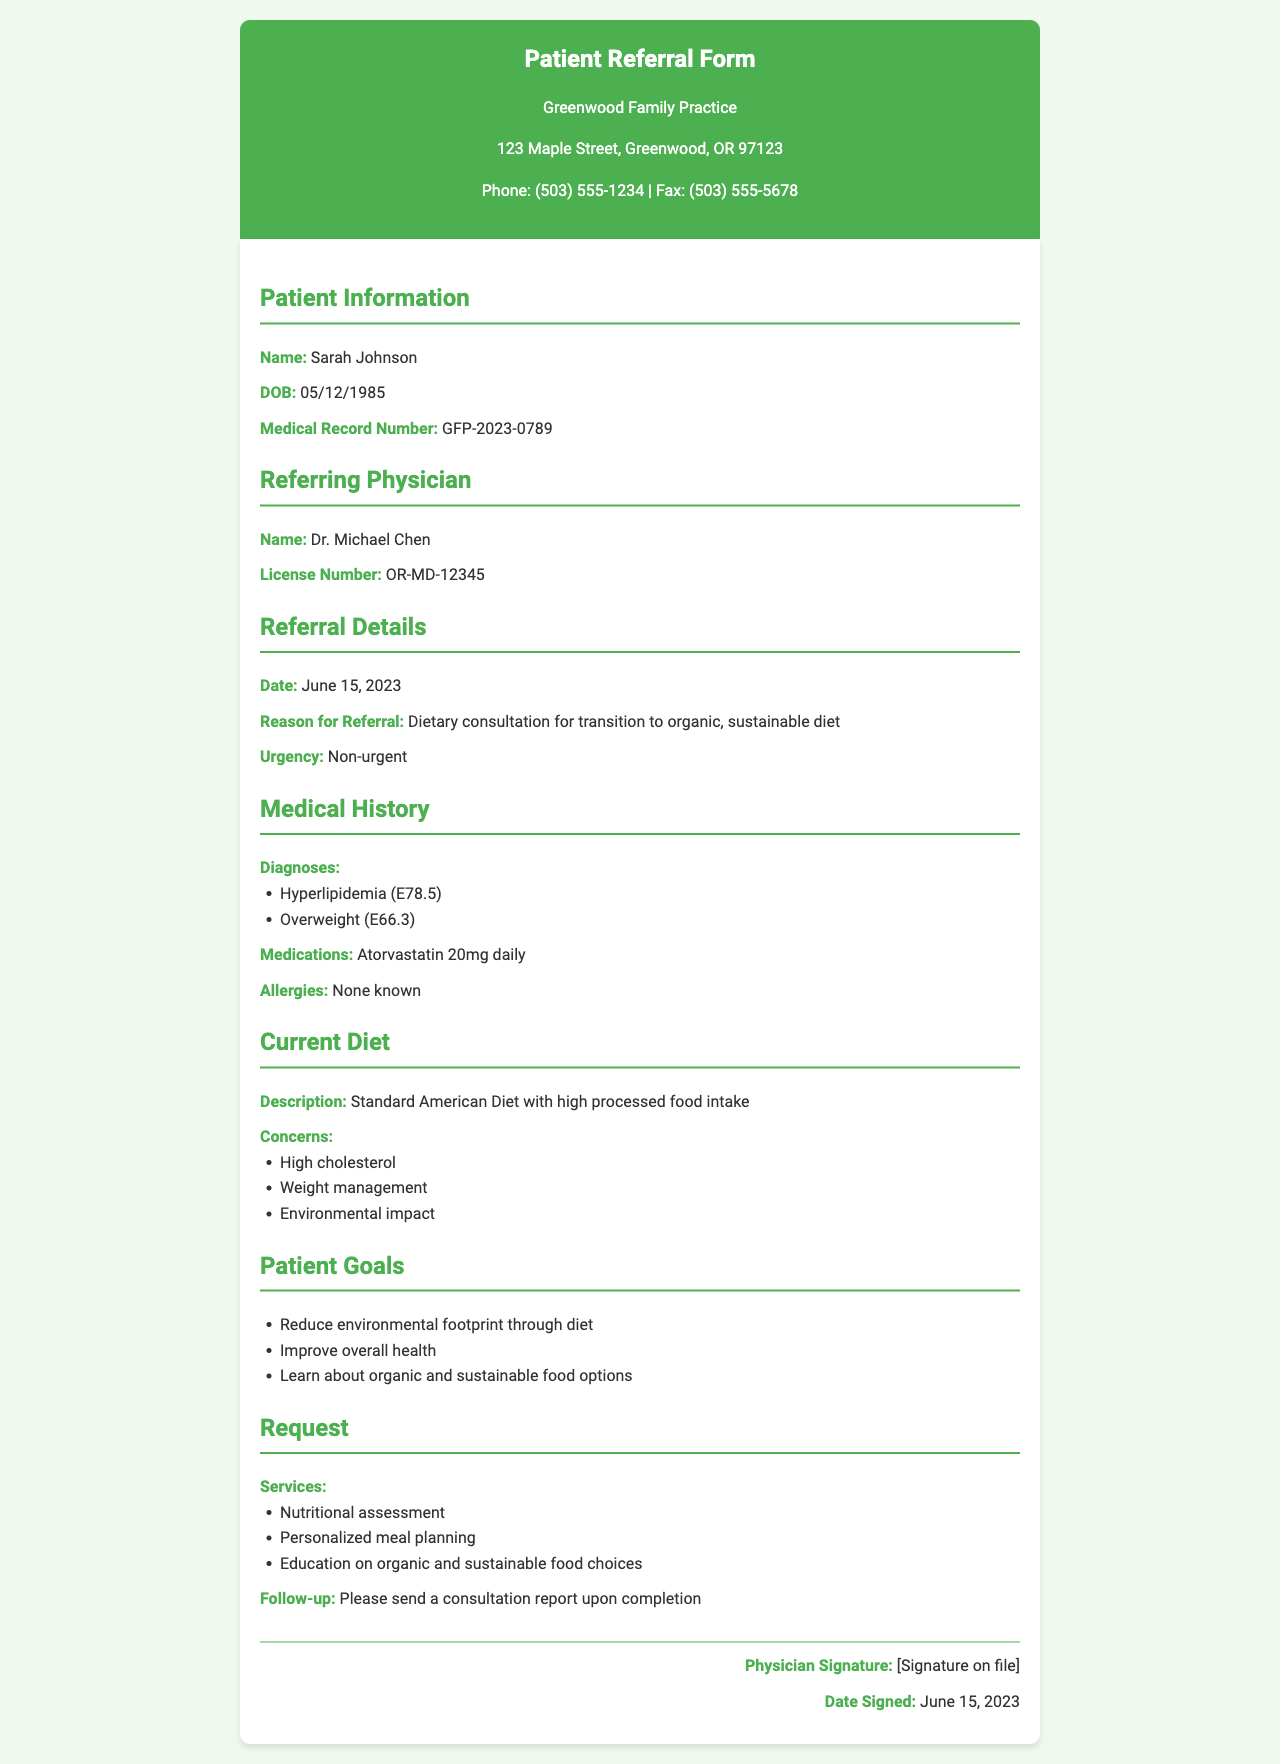What is the patient's name? The patient's name is stated in the Patient Information section of the document.
Answer: Sarah Johnson What is the date of the referral? The date of referral is mentioned under Referral Details.
Answer: June 15, 2023 Who is the referring physician? The name of the referring physician is specified in the Referring Physician section.
Answer: Dr. Michael Chen What is one of the patient's diagnoses? The patient's diagnoses can be found in the Medical History section, which lists several conditions.
Answer: Hyperlipidemia What is the patient's current diet described as? The description of the current diet is noted in the Current Diet section.
Answer: Standard American Diet with high processed food intake What is one goal the patient wants to achieve? The Patient Goals section lists multiple goals the patient has.
Answer: Reduce environmental footprint through diet What service is requested for consultation? The services requested are detailed in the Request section of the document.
Answer: Nutritional assessment What medication is the patient taking daily? The medication information is found in the Medical History section, which states the patient's medication regimen.
Answer: Atorvastatin 20mg daily What is the urgency of the referral? The urgency level is mentioned under Referral Details.
Answer: Non-urgent 